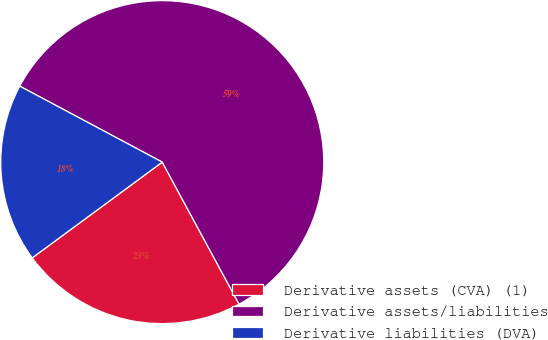Convert chart. <chart><loc_0><loc_0><loc_500><loc_500><pie_chart><fcel>Derivative assets (CVA) (1)<fcel>Derivative assets/liabilities<fcel>Derivative liabilities (DVA)<nl><fcel>22.79%<fcel>59.31%<fcel>17.9%<nl></chart> 